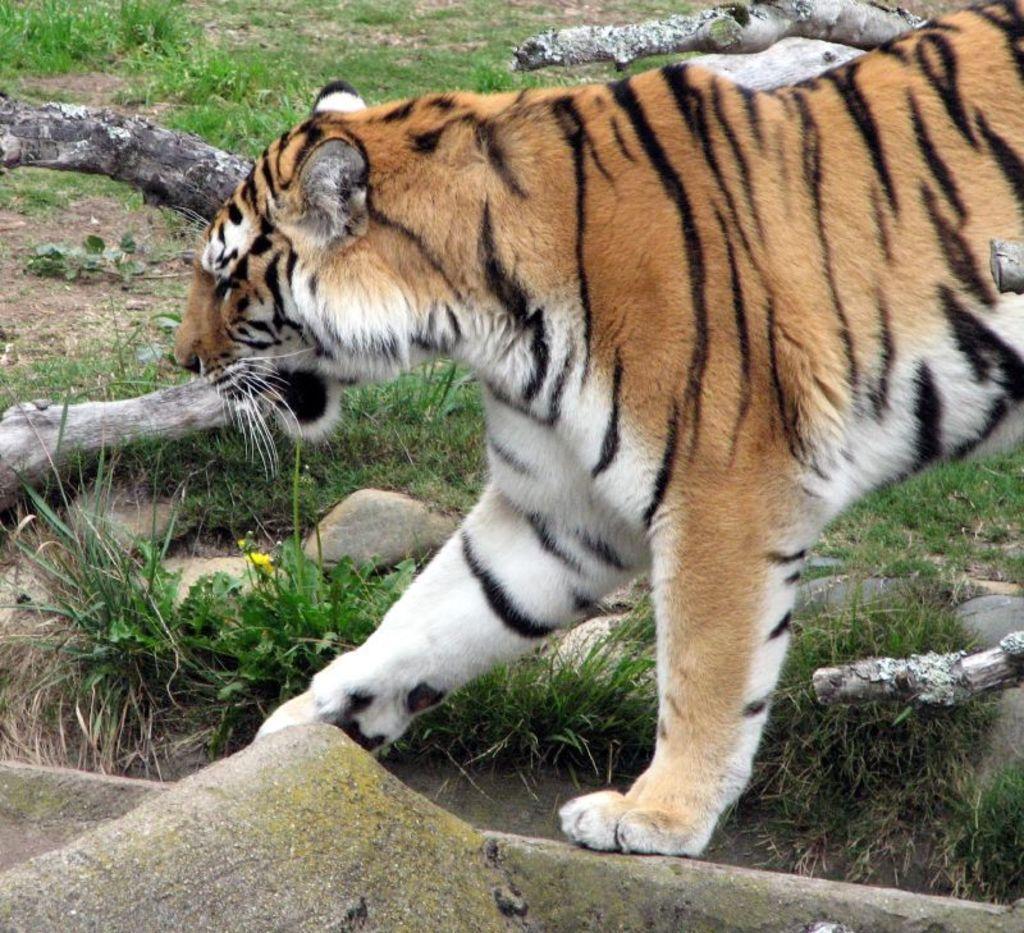Describe this image in one or two sentences. This picture is taken from outside of the city. In this image, we can see a cheetah walking on the land. In the background, we can see the grass. At the bottom, we can see a land with some stones and a grass. 